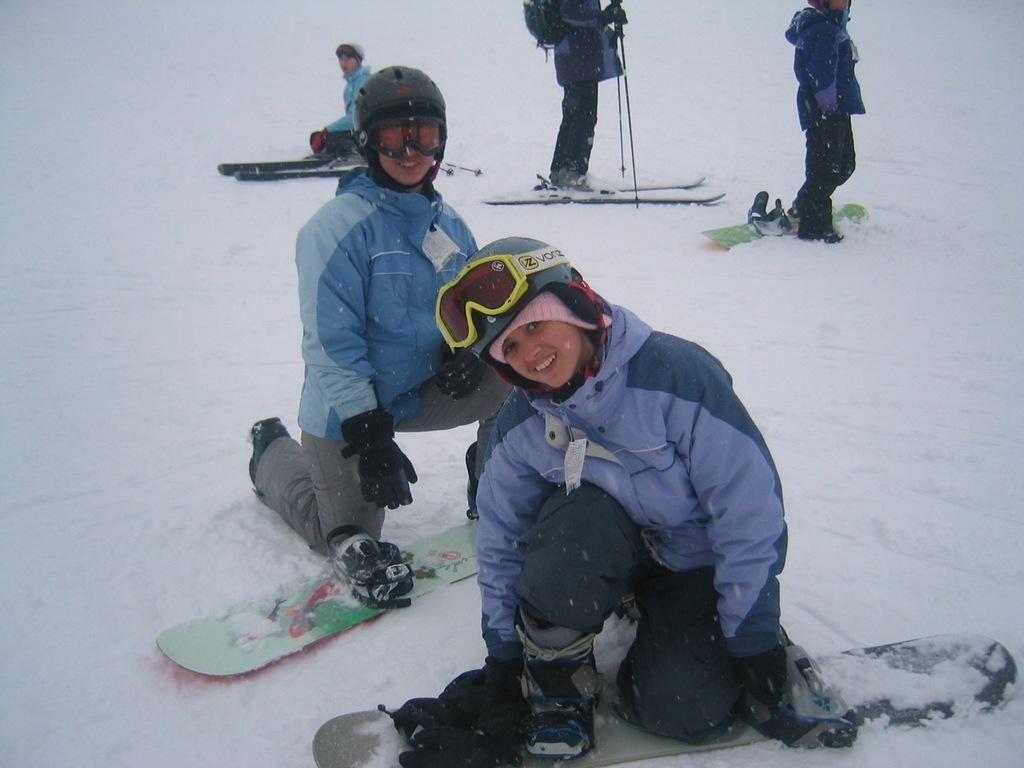How many people are in the image? There is a group of people in the image. What are the people wearing on their heads? The people are wearing helmets. What type of weather is depicted in the image? There is snow visible in the image. What equipment is being used by the people in the image? Snowboards and skis are present in the image. Can you see any cows in the image? No, there are no cows present in the image. What type of horses are being used by the people in the image? There are no horses present in the image; the people are using snowboards and skis. 